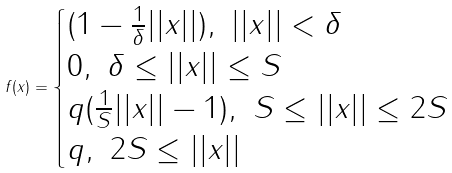<formula> <loc_0><loc_0><loc_500><loc_500>f ( x ) = \begin{cases} ( 1 - \frac { 1 } { \delta } | | x | | ) , \ | | x | | < \delta \\ 0 , \ \delta \leq | | x | | \leq S \\ q ( \frac { 1 } { S } | | x | | - 1 ) , \ S \leq | | x | | \leq 2 S \\ q , \ 2 S \leq | | x | | \end{cases}</formula> 